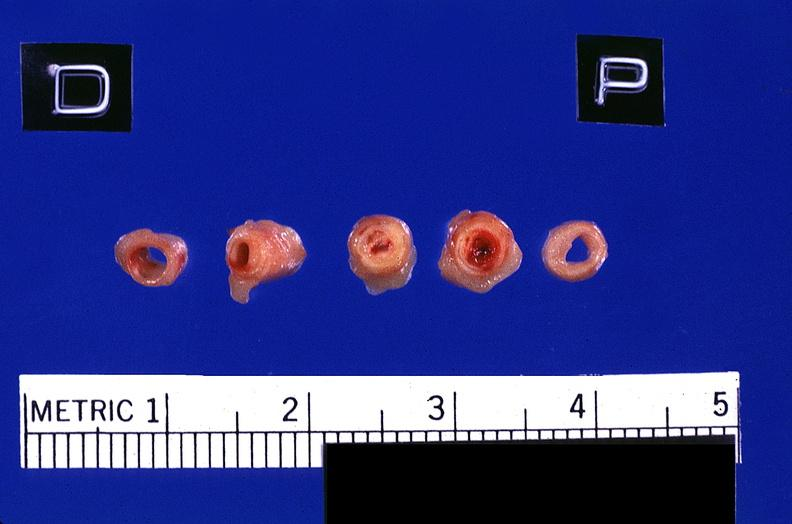where is this?
Answer the question using a single word or phrase. Vasculature 